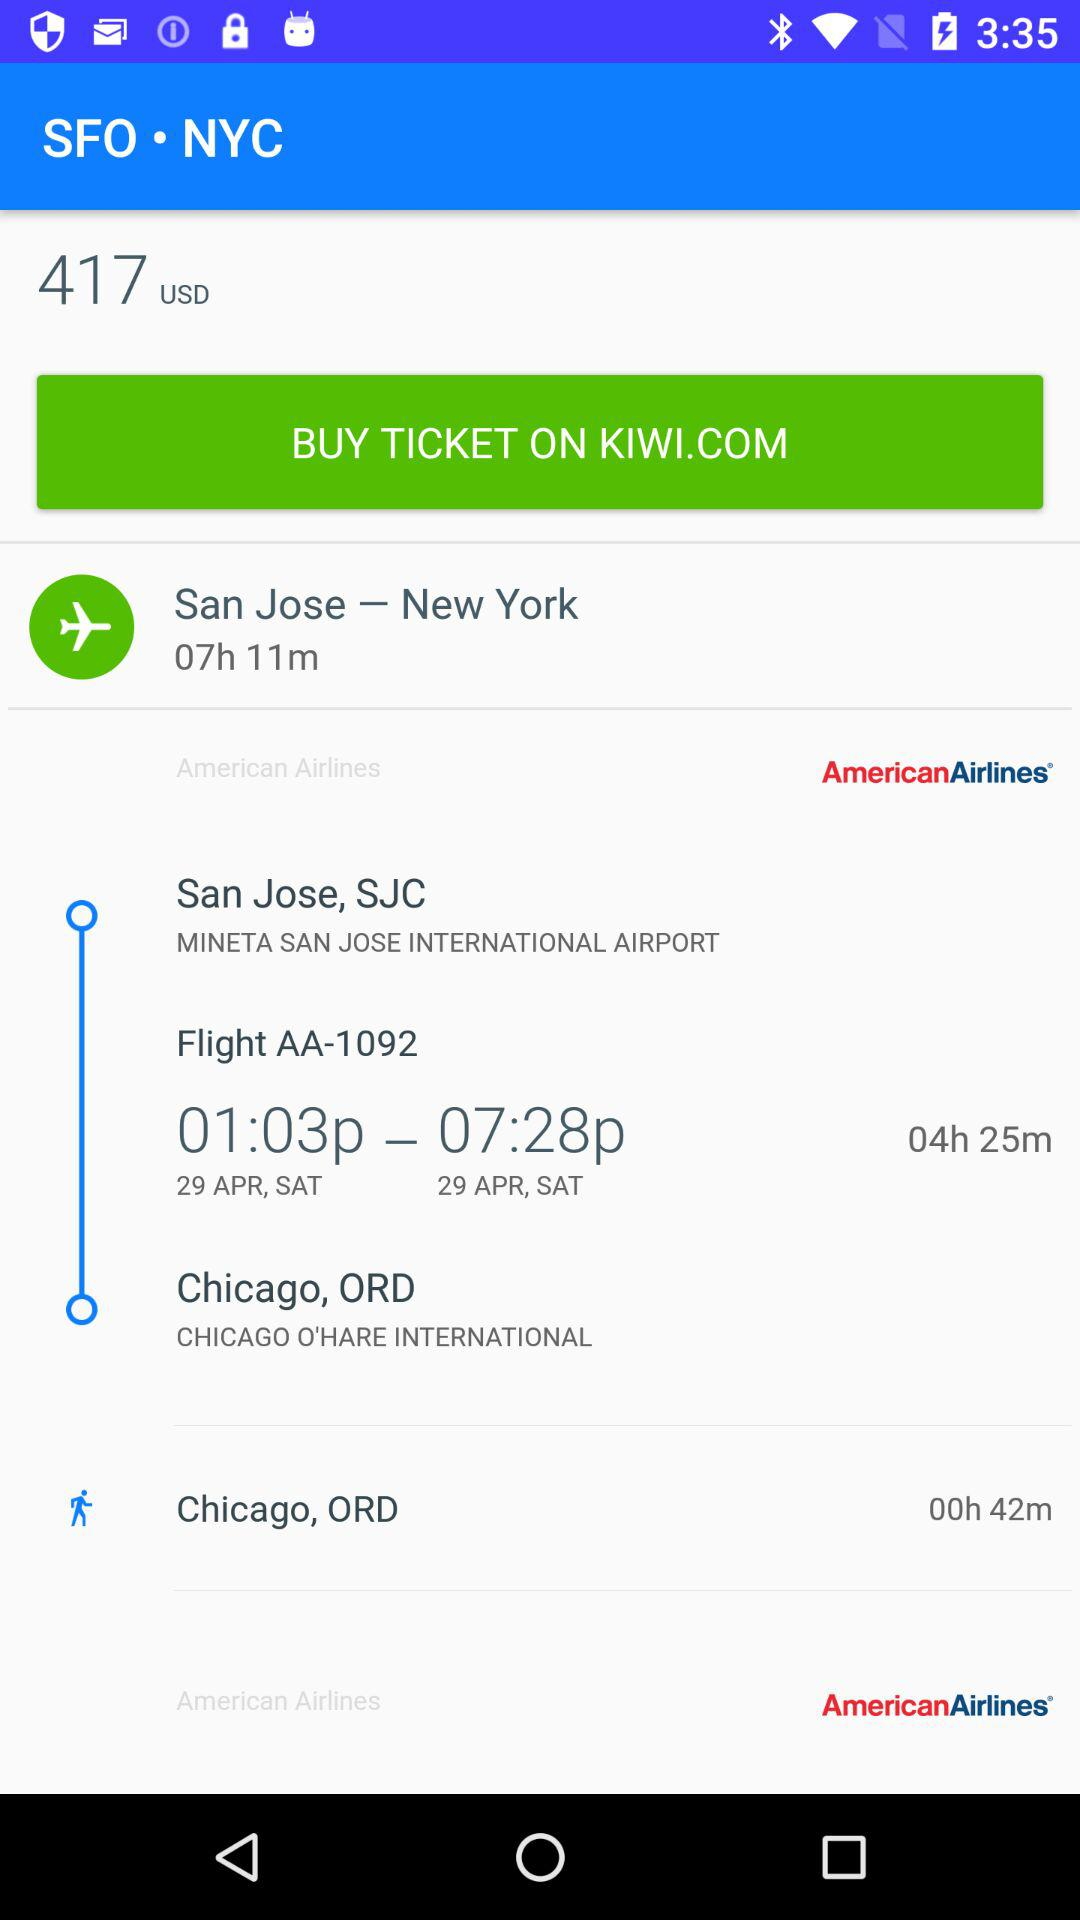What is the destination city name? The destination cities are New York and Chicago. 